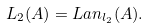<formula> <loc_0><loc_0><loc_500><loc_500>L _ { 2 } ( A ) = L a n _ { l _ { 2 } } ( A ) .</formula> 